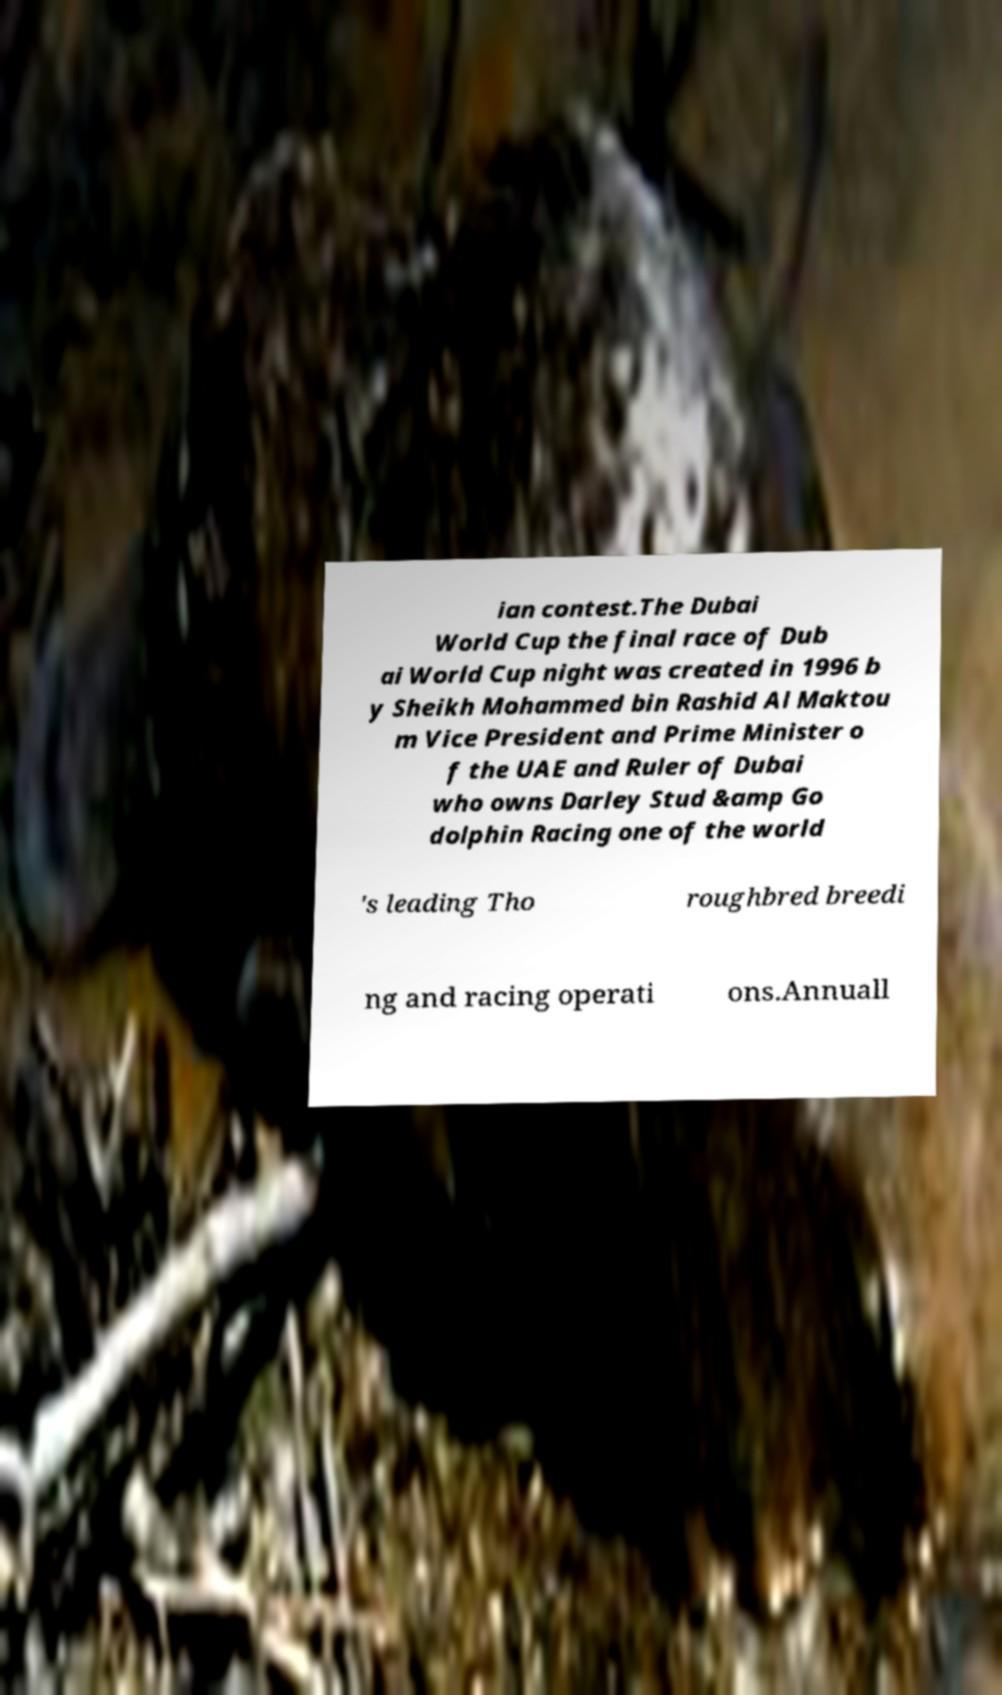Please read and relay the text visible in this image. What does it say? ian contest.The Dubai World Cup the final race of Dub ai World Cup night was created in 1996 b y Sheikh Mohammed bin Rashid Al Maktou m Vice President and Prime Minister o f the UAE and Ruler of Dubai who owns Darley Stud &amp Go dolphin Racing one of the world 's leading Tho roughbred breedi ng and racing operati ons.Annuall 